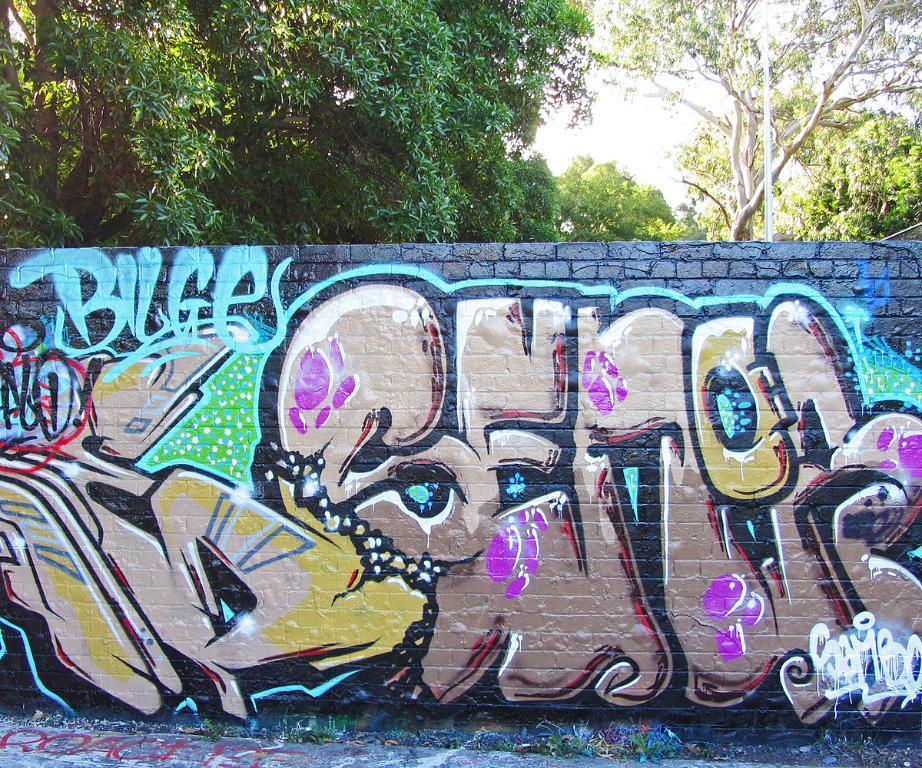Can you describe this image briefly? There is a painted wall in the middle of this image and there are some trees in the background. 